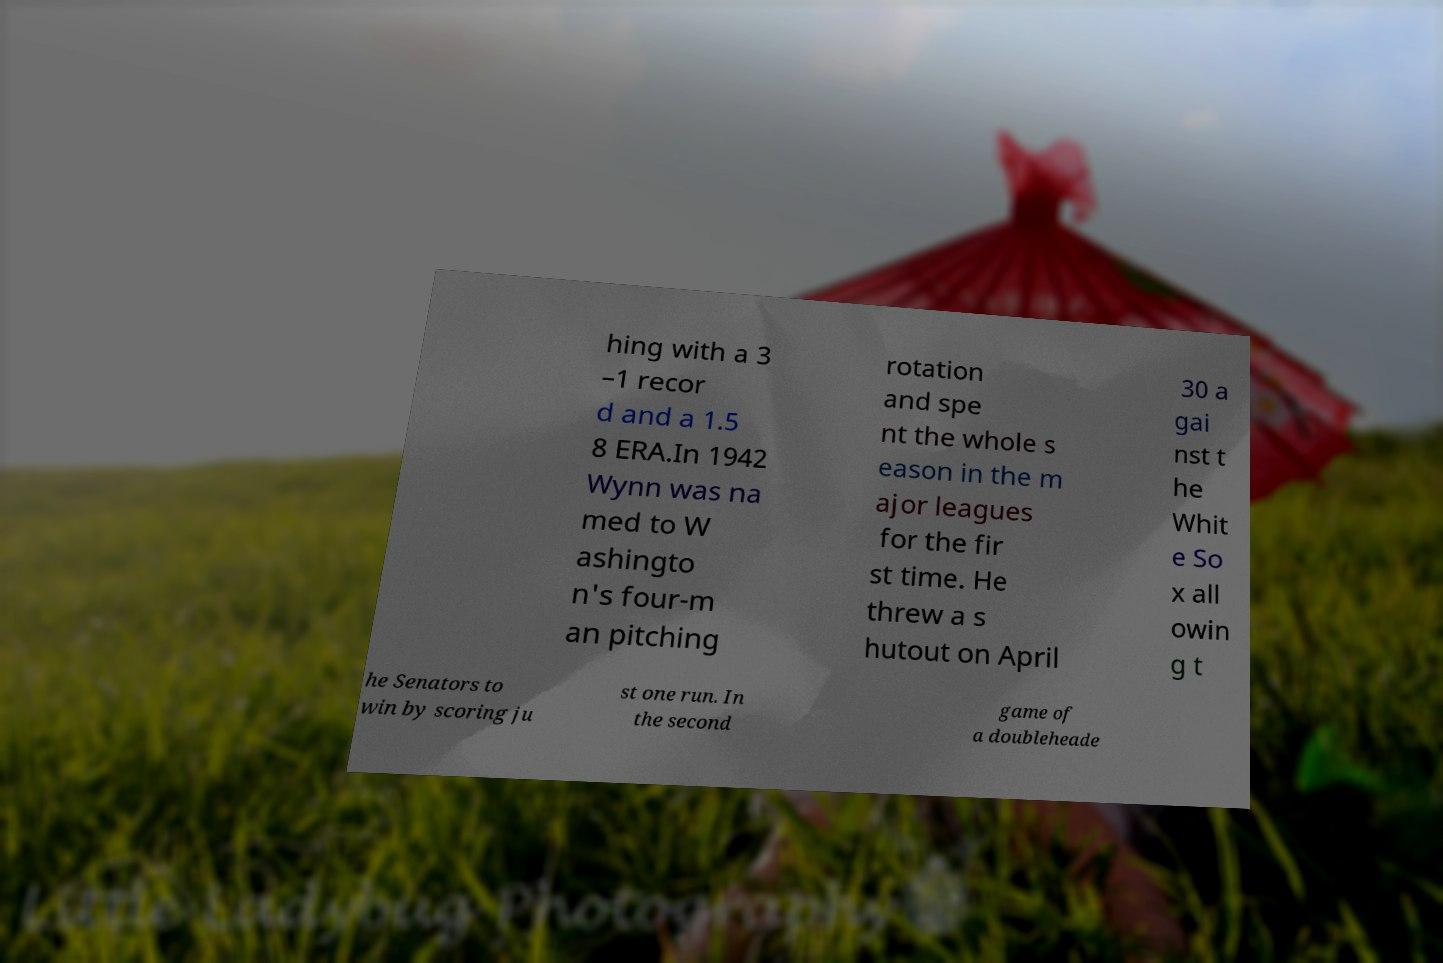Please identify and transcribe the text found in this image. hing with a 3 –1 recor d and a 1.5 8 ERA.In 1942 Wynn was na med to W ashingto n's four-m an pitching rotation and spe nt the whole s eason in the m ajor leagues for the fir st time. He threw a s hutout on April 30 a gai nst t he Whit e So x all owin g t he Senators to win by scoring ju st one run. In the second game of a doubleheade 